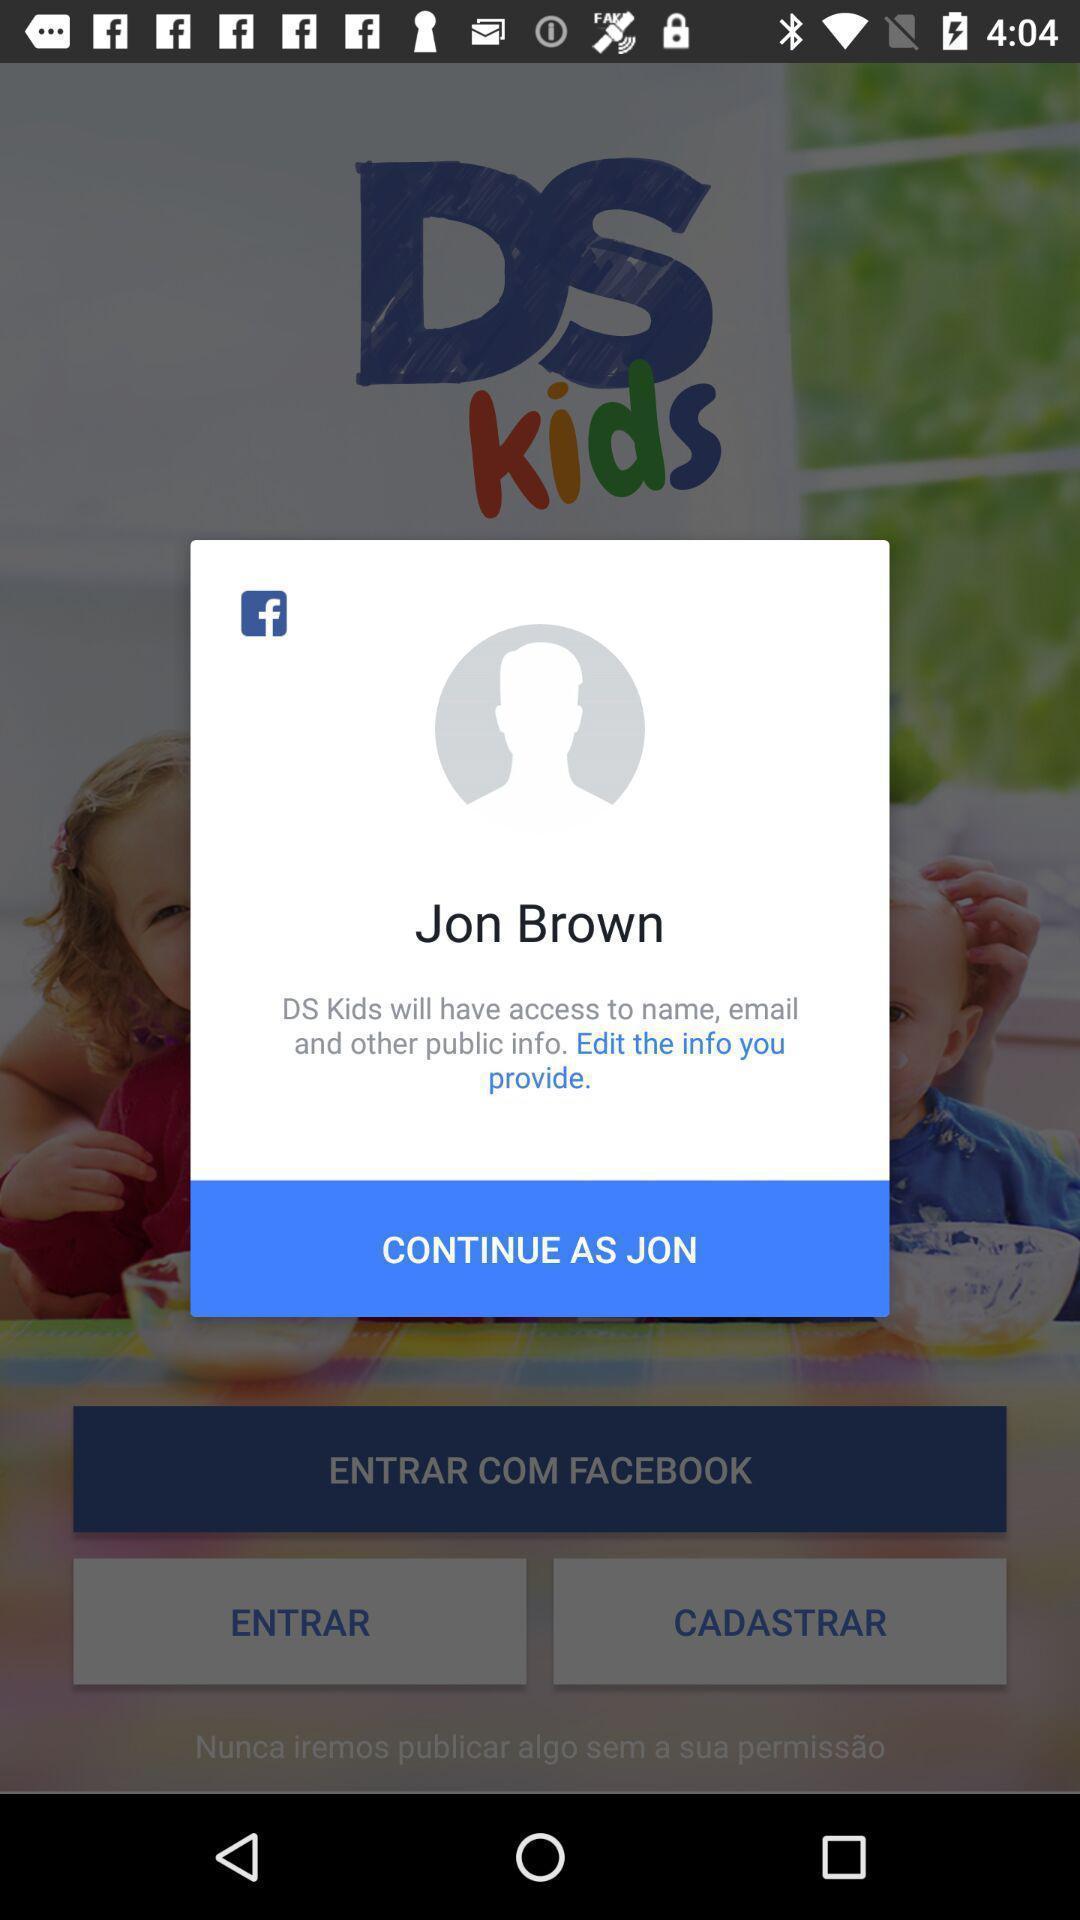Tell me about the visual elements in this screen capture. Pop-up showing to continue as info provided. 